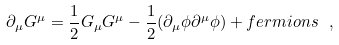Convert formula to latex. <formula><loc_0><loc_0><loc_500><loc_500>\partial _ { \mu } G ^ { \mu } = \frac { 1 } { 2 } G _ { \mu } G ^ { \mu } - \frac { 1 } { 2 } ( \partial _ { \mu } \phi \partial ^ { \mu } \phi ) + f e r m i o n s \ ,</formula> 